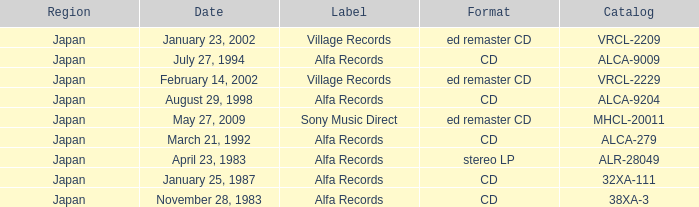Which catalog is in cd format? 38XA-3, 32XA-111, ALCA-279, ALCA-9009, ALCA-9204. 